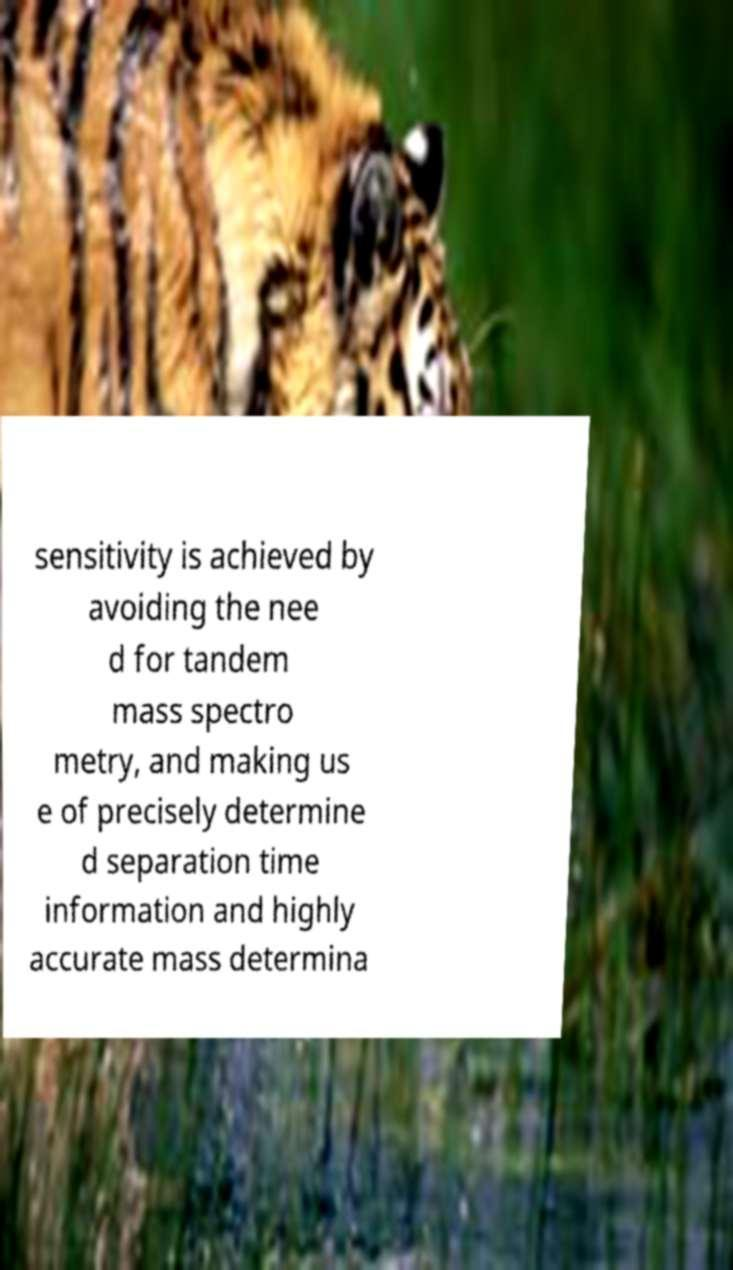Please identify and transcribe the text found in this image. sensitivity is achieved by avoiding the nee d for tandem mass spectro metry, and making us e of precisely determine d separation time information and highly accurate mass determina 